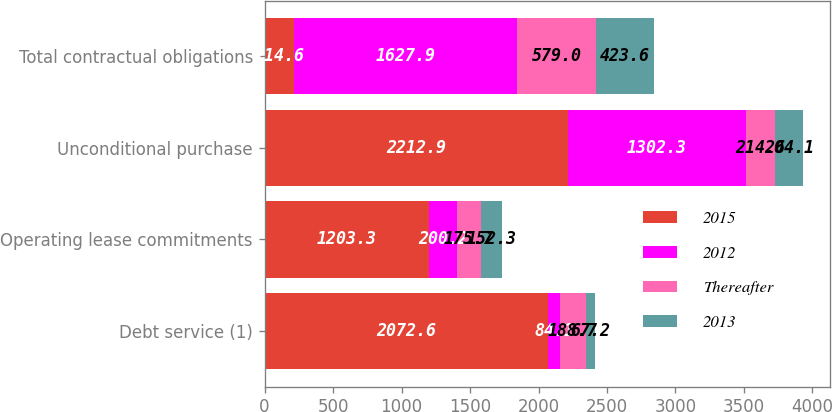<chart> <loc_0><loc_0><loc_500><loc_500><stacked_bar_chart><ecel><fcel>Debt service (1)<fcel>Operating lease commitments<fcel>Unconditional purchase<fcel>Total contractual obligations<nl><fcel>2015<fcel>2072.6<fcel>1203.3<fcel>2212.9<fcel>214.6<nl><fcel>2012<fcel>84.1<fcel>200.2<fcel>1302.3<fcel>1627.9<nl><fcel>Thereafter<fcel>188.7<fcel>175.7<fcel>214.6<fcel>579<nl><fcel>2013<fcel>67.2<fcel>152.3<fcel>204.1<fcel>423.6<nl></chart> 